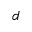<formula> <loc_0><loc_0><loc_500><loc_500>d</formula> 